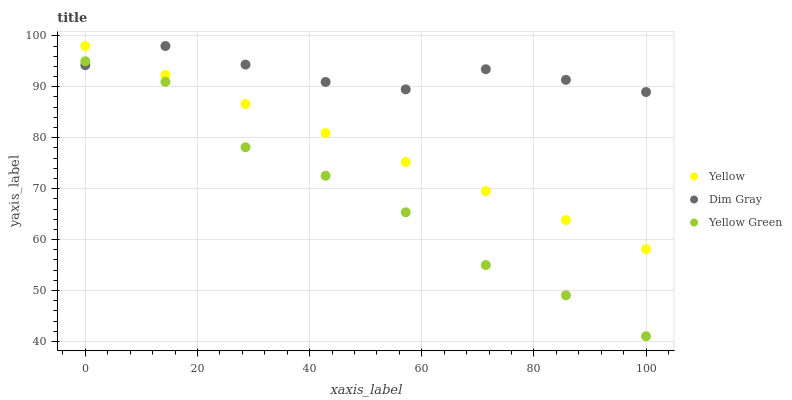Does Yellow Green have the minimum area under the curve?
Answer yes or no. Yes. Does Dim Gray have the maximum area under the curve?
Answer yes or no. Yes. Does Yellow have the minimum area under the curve?
Answer yes or no. No. Does Yellow have the maximum area under the curve?
Answer yes or no. No. Is Yellow the smoothest?
Answer yes or no. Yes. Is Yellow Green the roughest?
Answer yes or no. Yes. Is Yellow Green the smoothest?
Answer yes or no. No. Is Yellow the roughest?
Answer yes or no. No. Does Yellow Green have the lowest value?
Answer yes or no. Yes. Does Yellow have the lowest value?
Answer yes or no. No. Does Yellow have the highest value?
Answer yes or no. Yes. Does Yellow Green have the highest value?
Answer yes or no. No. Is Yellow Green less than Yellow?
Answer yes or no. Yes. Is Yellow greater than Yellow Green?
Answer yes or no. Yes. Does Dim Gray intersect Yellow Green?
Answer yes or no. Yes. Is Dim Gray less than Yellow Green?
Answer yes or no. No. Is Dim Gray greater than Yellow Green?
Answer yes or no. No. Does Yellow Green intersect Yellow?
Answer yes or no. No. 